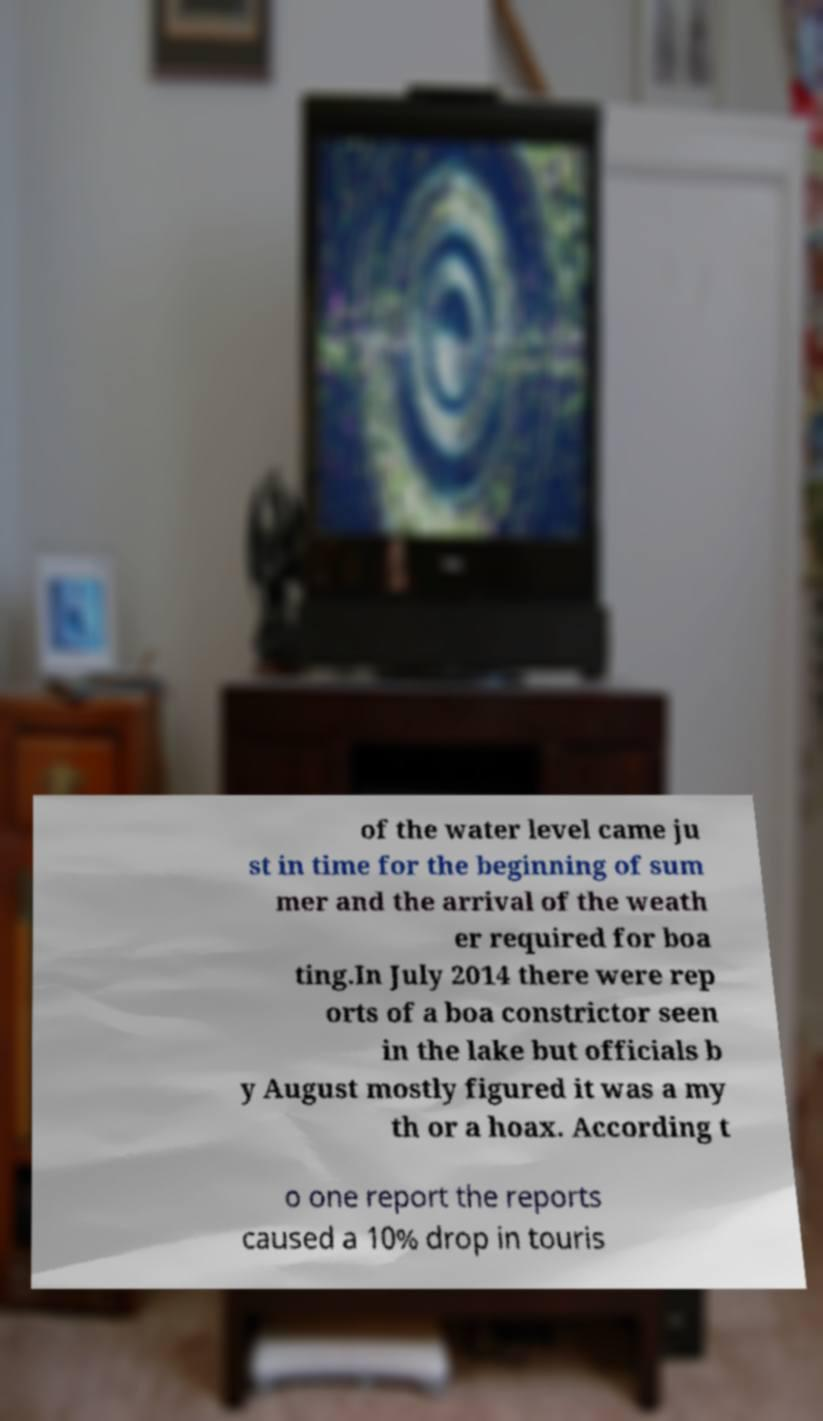Can you read and provide the text displayed in the image?This photo seems to have some interesting text. Can you extract and type it out for me? of the water level came ju st in time for the beginning of sum mer and the arrival of the weath er required for boa ting.In July 2014 there were rep orts of a boa constrictor seen in the lake but officials b y August mostly figured it was a my th or a hoax. According t o one report the reports caused a 10% drop in touris 